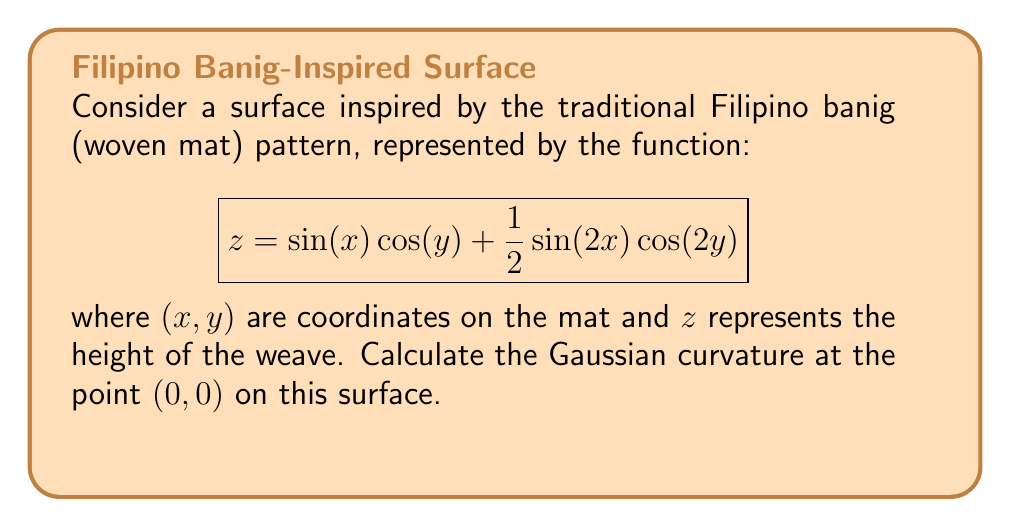Could you help me with this problem? To calculate the Gaussian curvature at $(0,0)$, we need to follow these steps:

1) First, recall that the Gaussian curvature $K$ is given by:

   $$K = \frac{LN - M^2}{EG - F^2}$$

   where $L$, $M$, $N$ are coefficients of the second fundamental form, and $E$, $F$, $G$ are coefficients of the first fundamental form.

2) Let's calculate the partial derivatives:

   $$f_x = \cos(x)\cos(y) + \cos(2x)\cos(2y)$$
   $$f_y = -\sin(x)\sin(y) - \sin(2x)\sin(2y)$$
   $$f_{xx} = -\sin(x)\cos(y) - 2\sin(2x)\cos(2y)$$
   $$f_{yy} = -\sin(x)\cos(y) - 2\sin(2x)\cos(2y)$$
   $$f_{xy} = -\cos(x)\sin(y) - 2\cos(2x)\sin(2y)$$

3) At $(0,0)$, these evaluate to:

   $$f_x(0,0) = 2, f_y(0,0) = 0$$
   $$f_{xx}(0,0) = 0, f_{yy}(0,0) = 0, f_{xy}(0,0) = 0$$

4) Now we can calculate the coefficients of the first fundamental form:

   $$E = 1 + f_x^2 = 5$$
   $$F = f_x f_y = 0$$
   $$G = 1 + f_y^2 = 1$$

5) And the coefficients of the second fundamental form:

   $$L = \frac{f_{xx}}{\sqrt{1 + f_x^2 + f_y^2}} = 0$$
   $$M = \frac{f_{xy}}{\sqrt{1 + f_x^2 + f_y^2}} = 0$$
   $$N = \frac{f_{yy}}{\sqrt{1 + f_x^2 + f_y^2}} = 0$$

6) Substituting these into the formula for Gaussian curvature:

   $$K = \frac{LN - M^2}{EG - F^2} = \frac{0 - 0}{5(1) - 0} = 0$$

Therefore, the Gaussian curvature at $(0,0)$ is 0.
Answer: $K = 0$ 